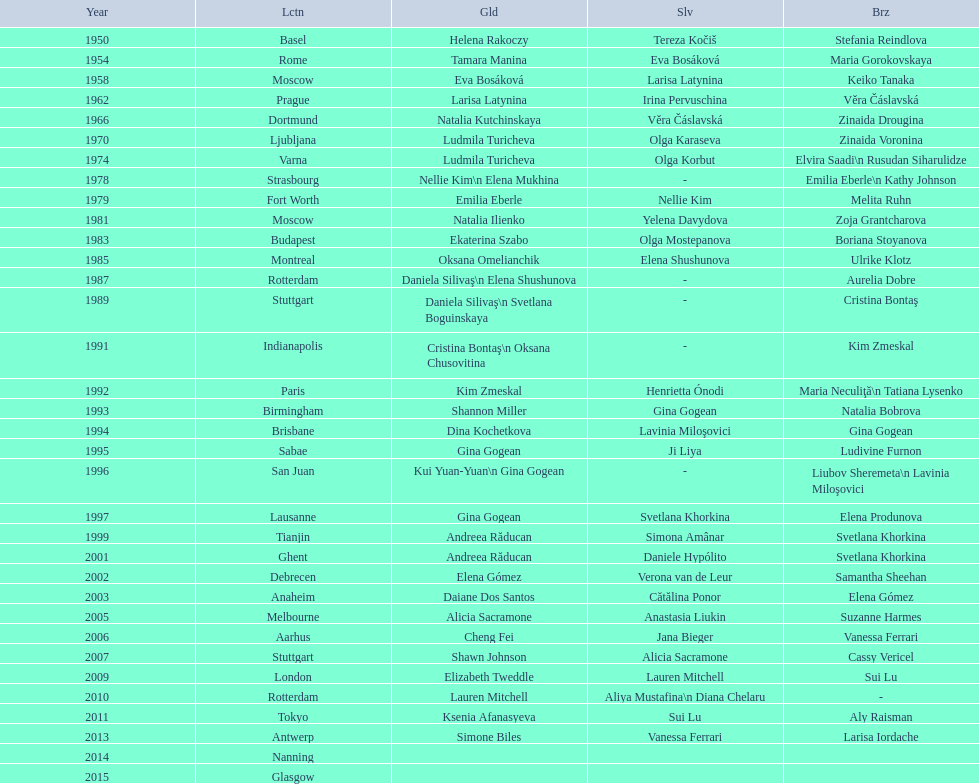What is the number of times a brazilian has won a medal? 2. 